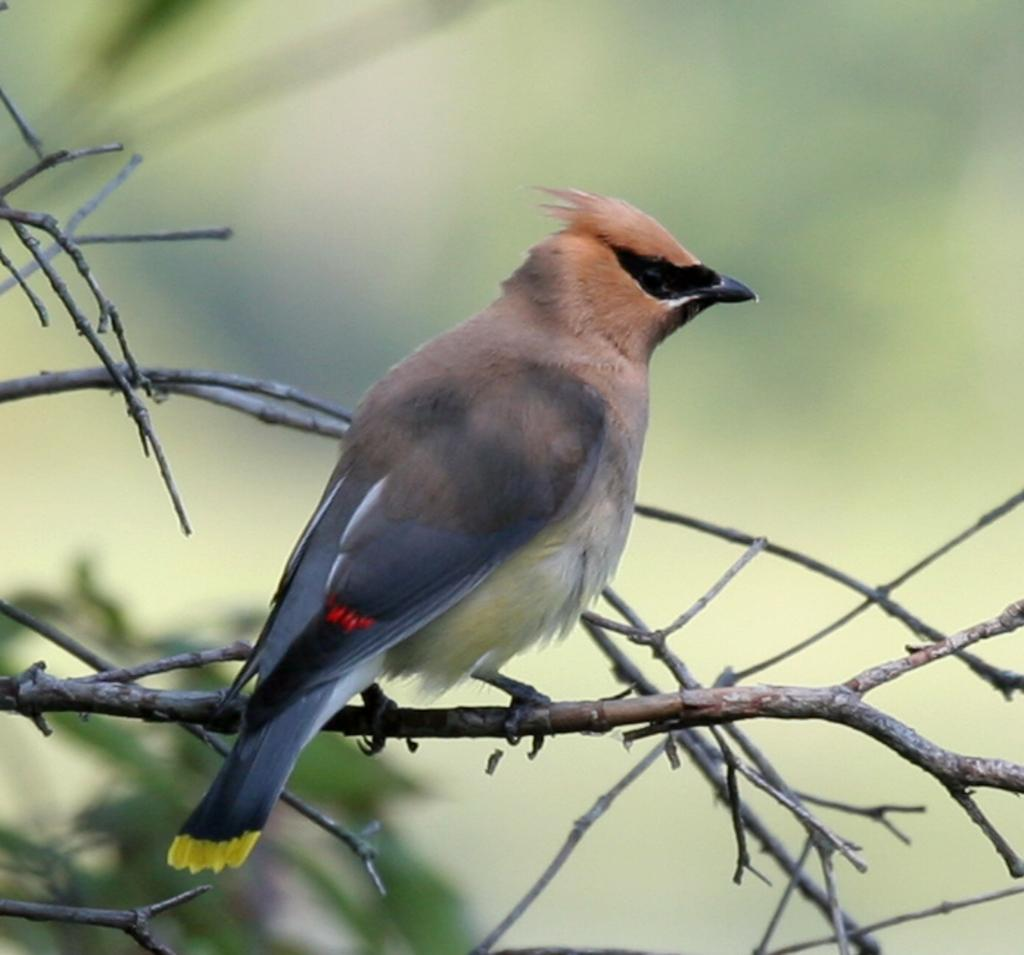What type of animal can be seen in the image? There is a bird in the image. Where is the bird located in the image? The bird is sitting on a stem. What nerve is responsible for the bird's ability to fly in the image? There is no mention of the bird flying in the image, and the bird's nervous system is not visible. Additionally, the question of which nerve is responsible for a specific action is beyond the scope of the image. 